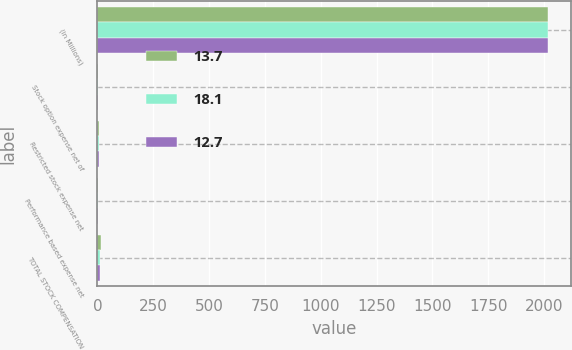Convert chart. <chart><loc_0><loc_0><loc_500><loc_500><stacked_bar_chart><ecel><fcel>(in Millions)<fcel>Stock option expense net of<fcel>Restricted stock expense net<fcel>Performance based expense net<fcel>TOTAL STOCK COMPENSATION<nl><fcel>13.7<fcel>2018<fcel>4.9<fcel>8.4<fcel>4.4<fcel>18.1<nl><fcel>18.1<fcel>2017<fcel>4.5<fcel>6.4<fcel>2.8<fcel>13.7<nl><fcel>12.7<fcel>2016<fcel>4.4<fcel>6.5<fcel>1.8<fcel>12.7<nl></chart> 